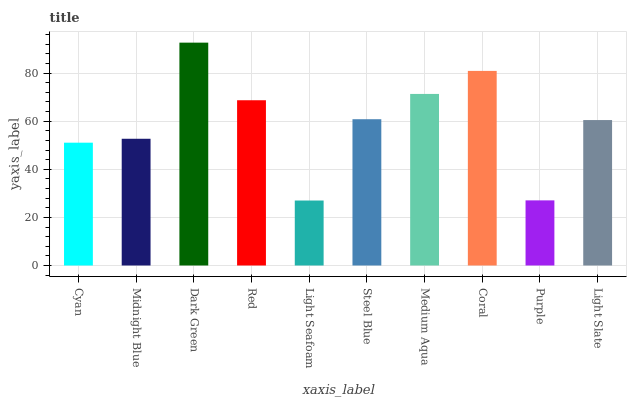Is Light Seafoam the minimum?
Answer yes or no. Yes. Is Dark Green the maximum?
Answer yes or no. Yes. Is Midnight Blue the minimum?
Answer yes or no. No. Is Midnight Blue the maximum?
Answer yes or no. No. Is Midnight Blue greater than Cyan?
Answer yes or no. Yes. Is Cyan less than Midnight Blue?
Answer yes or no. Yes. Is Cyan greater than Midnight Blue?
Answer yes or no. No. Is Midnight Blue less than Cyan?
Answer yes or no. No. Is Steel Blue the high median?
Answer yes or no. Yes. Is Light Slate the low median?
Answer yes or no. Yes. Is Light Seafoam the high median?
Answer yes or no. No. Is Light Seafoam the low median?
Answer yes or no. No. 